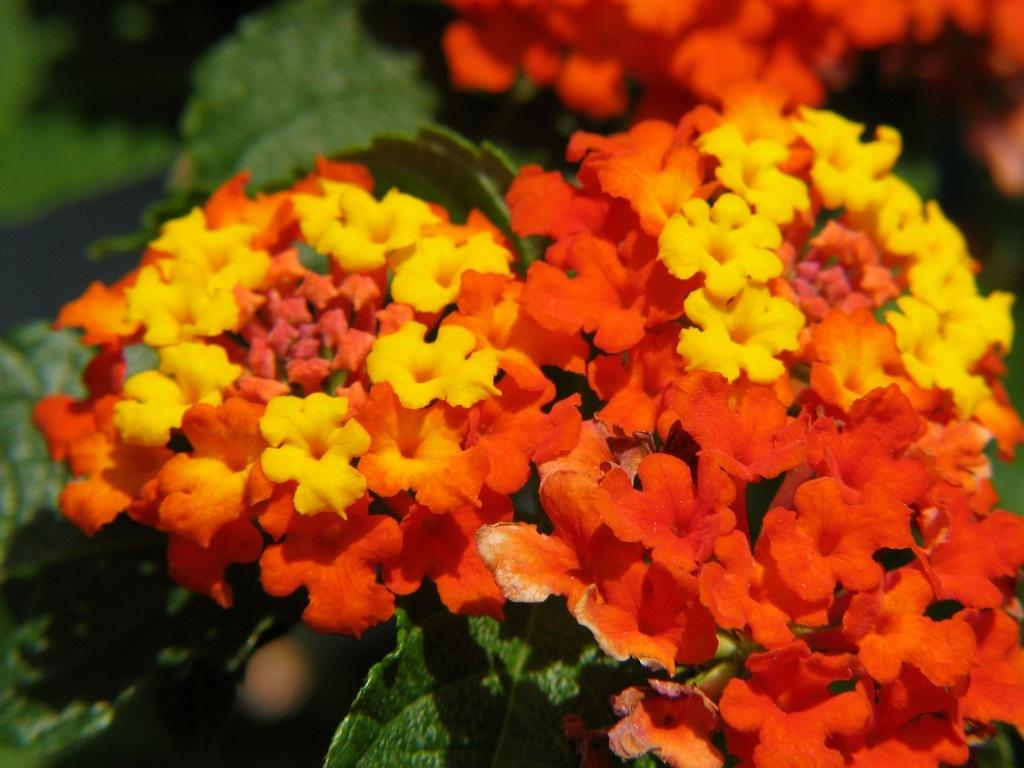What type of flowers can be seen in the image? There is a group of yellow and red flowers in the image. What else can be seen in the background of the image? There are leaves visible in the background of the image. How does the wave affect the flowers in the image? There is no wave present in the image, so it does not affect the flowers. 